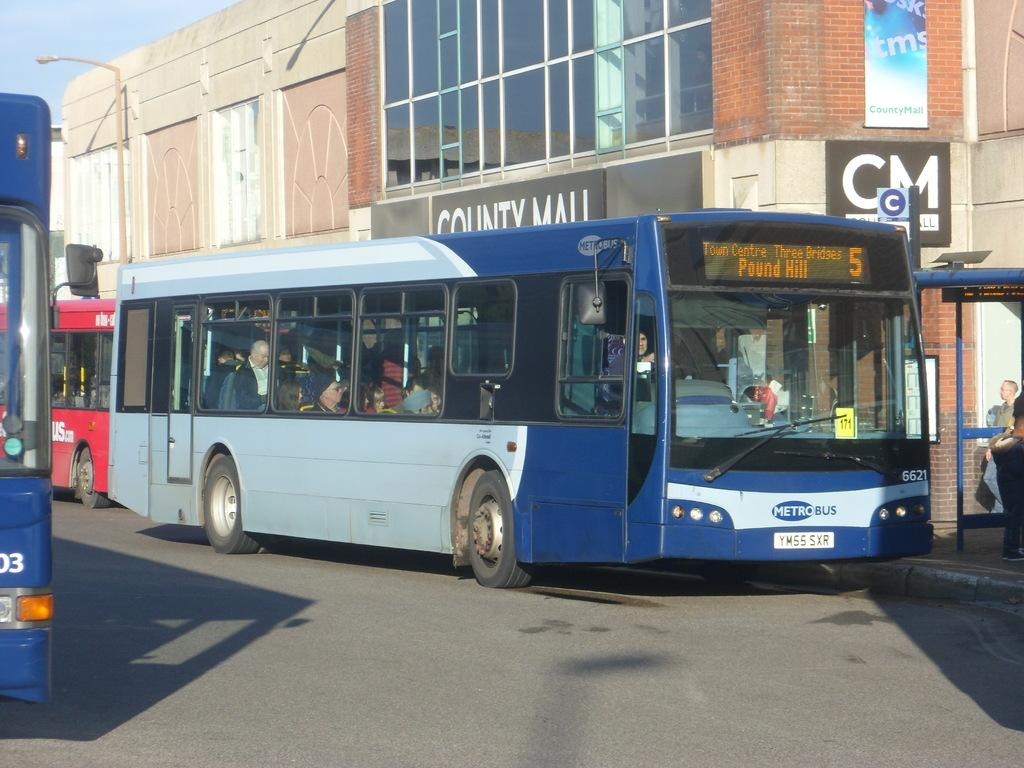Provide a one-sentence caption for the provided image. A Metro bus is driving past the County Mall building. 